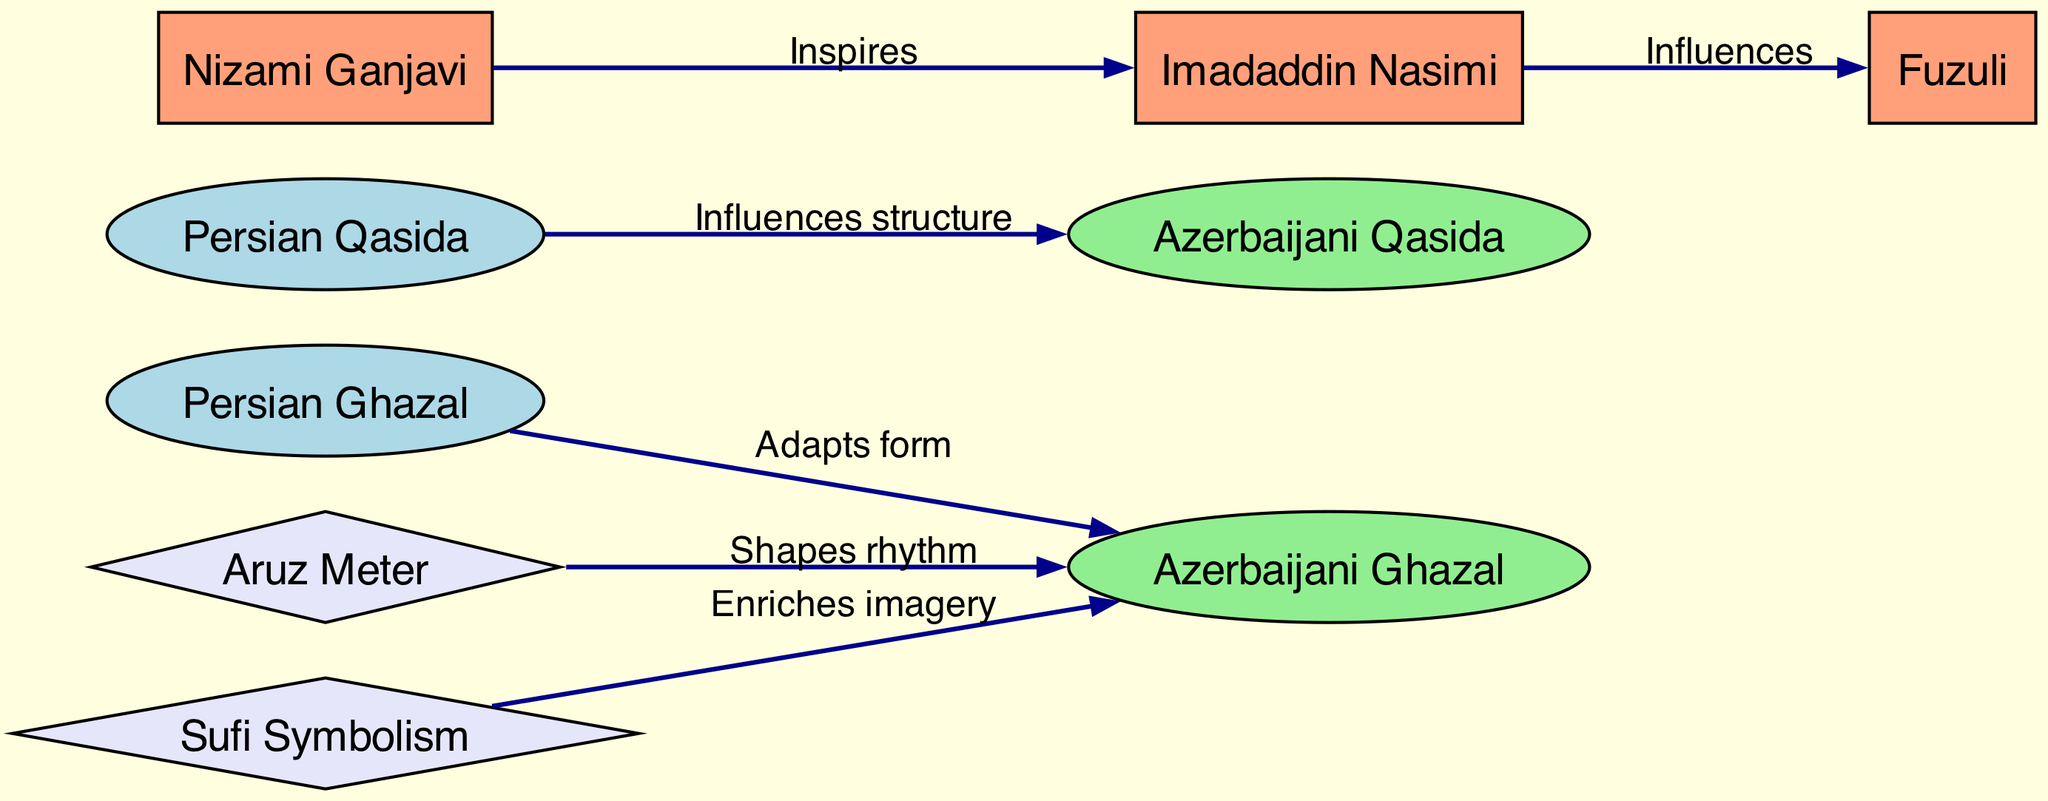What is one poetic form that influenced Azerbaijani Ghazal? The diagram indicates that the Persian Ghazal adapts its form to influence the Azerbaijani Ghazal directly. Therefore, the Persian Ghazal is a specific poetic form that has been acknowledged for this influence.
Answer: Persian Ghazal How many nodes are there in this diagram? By counting all the unique entities represented in the diagram, we can see that there are a total of eight nodes.
Answer: 8 Which Azerbaijani poet was inspired by Nizami Ganjavi? The arrow labeled "Inspires" originates from Nizami Ganjavi and points to Imadaddin Nasimi, indicating that Nasimi is the Azerbaijani poet inspired by Nizami Ganjavi.
Answer: Imadaddin Nasimi What kind of meter shapes Azerbaijani Ghazal's rhythm? The diagram shows that Aruz Meter has a direct relationship with Azerbaijani Ghazal and specifically states that it "Shapes rhythm." Thus, the Aruz Meter is responsible for shaping the rhythm of the Azerbaijani Ghazal.
Answer: Aruz Meter What type of symbolism enriches the imagery of Azerbaijani Ghazal? The connection in the diagram indicates that Sufi Symbolism flows towards Azerbaijani Ghazal with the label "Enriches imagery." Thus, Sufi Symbolism is the type of symbolism that enriches this imagery.
Answer: Sufi Symbolism Which poet influences Fuzuli? According to the diagram, Imadaddin Nasimi influences Fuzuli, as shown by the directed edge labeled "Influences." Thus, Imadaddin Nasimi is the poet who influences Fuzuli.
Answer: Imadaddin Nasimi Which poetic form is influenced structurally by the Persian Qasida? The diagram clearly states that the Persian Qasida influences the Azerbaijani Qasida with the label "Influences structure." Therefore, the Azerbaijani Qasida is the poetic form that is influenced structurally.
Answer: Azerbaijani Qasida What is the relationship between Persian Ghazal and Azerbaijani Ghazal? The diagram indicates a directed arrow showing that Persian Ghazal "Adapts form" to become Azerbaijani Ghazal, symbolizing the transformation from the Persian version to the Azerbaijani version. This indicates a direct influence where the Persian form is modified for the Azerbaijani context.
Answer: Adapts form 